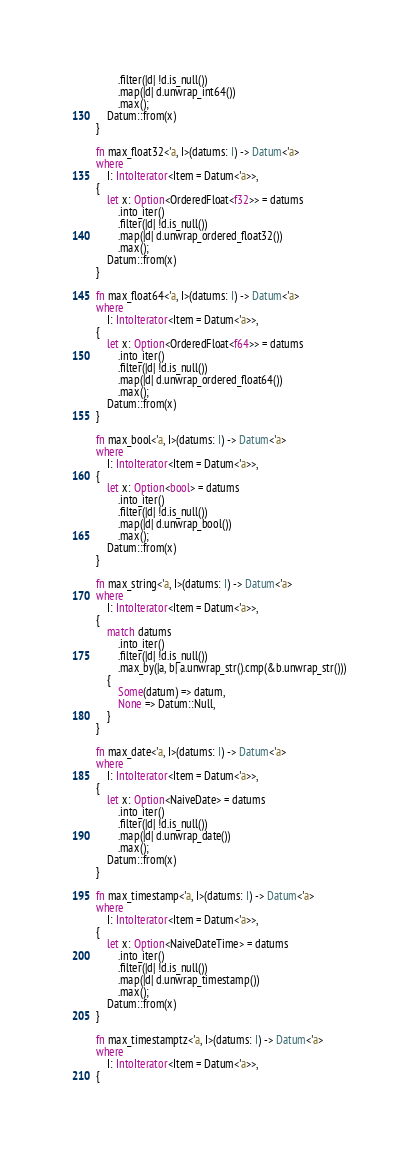Convert code to text. <code><loc_0><loc_0><loc_500><loc_500><_Rust_>        .filter(|d| !d.is_null())
        .map(|d| d.unwrap_int64())
        .max();
    Datum::from(x)
}

fn max_float32<'a, I>(datums: I) -> Datum<'a>
where
    I: IntoIterator<Item = Datum<'a>>,
{
    let x: Option<OrderedFloat<f32>> = datums
        .into_iter()
        .filter(|d| !d.is_null())
        .map(|d| d.unwrap_ordered_float32())
        .max();
    Datum::from(x)
}

fn max_float64<'a, I>(datums: I) -> Datum<'a>
where
    I: IntoIterator<Item = Datum<'a>>,
{
    let x: Option<OrderedFloat<f64>> = datums
        .into_iter()
        .filter(|d| !d.is_null())
        .map(|d| d.unwrap_ordered_float64())
        .max();
    Datum::from(x)
}

fn max_bool<'a, I>(datums: I) -> Datum<'a>
where
    I: IntoIterator<Item = Datum<'a>>,
{
    let x: Option<bool> = datums
        .into_iter()
        .filter(|d| !d.is_null())
        .map(|d| d.unwrap_bool())
        .max();
    Datum::from(x)
}

fn max_string<'a, I>(datums: I) -> Datum<'a>
where
    I: IntoIterator<Item = Datum<'a>>,
{
    match datums
        .into_iter()
        .filter(|d| !d.is_null())
        .max_by(|a, b| a.unwrap_str().cmp(&b.unwrap_str()))
    {
        Some(datum) => datum,
        None => Datum::Null,
    }
}

fn max_date<'a, I>(datums: I) -> Datum<'a>
where
    I: IntoIterator<Item = Datum<'a>>,
{
    let x: Option<NaiveDate> = datums
        .into_iter()
        .filter(|d| !d.is_null())
        .map(|d| d.unwrap_date())
        .max();
    Datum::from(x)
}

fn max_timestamp<'a, I>(datums: I) -> Datum<'a>
where
    I: IntoIterator<Item = Datum<'a>>,
{
    let x: Option<NaiveDateTime> = datums
        .into_iter()
        .filter(|d| !d.is_null())
        .map(|d| d.unwrap_timestamp())
        .max();
    Datum::from(x)
}

fn max_timestamptz<'a, I>(datums: I) -> Datum<'a>
where
    I: IntoIterator<Item = Datum<'a>>,
{</code> 